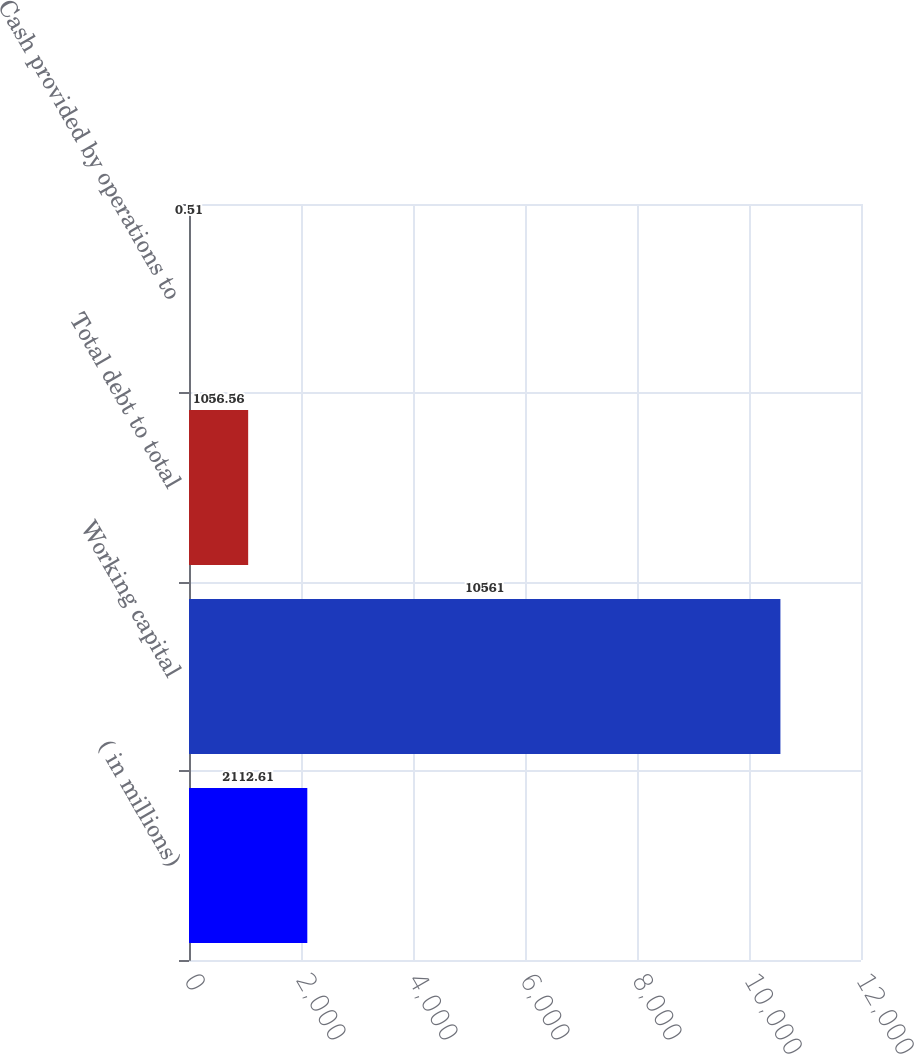Convert chart to OTSL. <chart><loc_0><loc_0><loc_500><loc_500><bar_chart><fcel>( in millions)<fcel>Working capital<fcel>Total debt to total<fcel>Cash provided by operations to<nl><fcel>2112.61<fcel>10561<fcel>1056.56<fcel>0.51<nl></chart> 